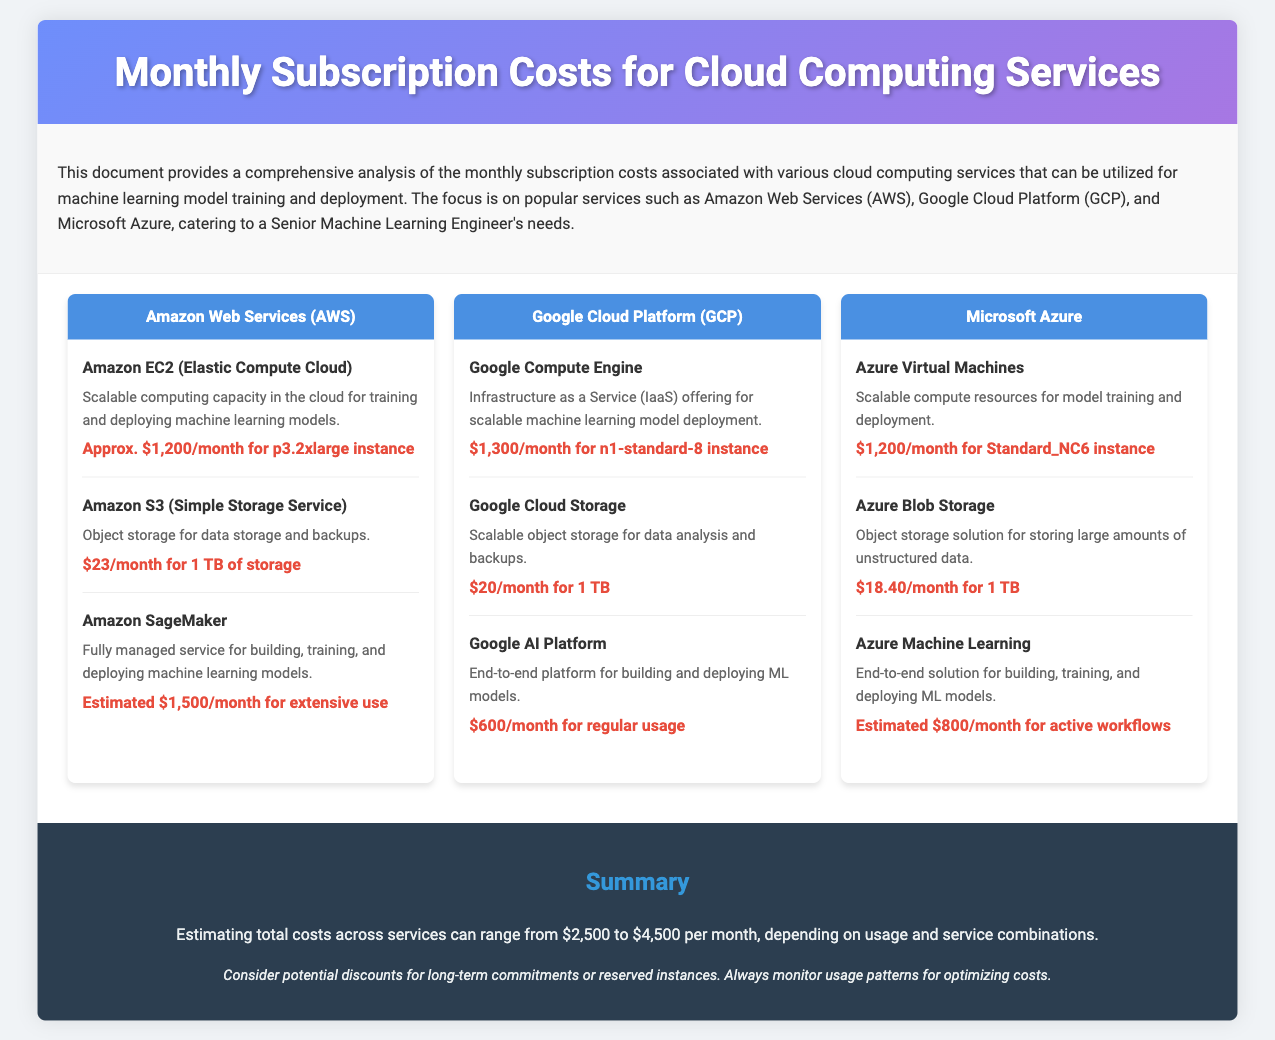What is the cost of Amazon EC2? The cost of Amazon EC2 is specified in the document as approximately $1,200 per month for the p3.2xlarge instance.
Answer: $1,200/month How much does Azure Blob Storage cost? The document lists the cost of Azure Blob Storage as $18.40 per month for 1 TB.
Answer: $18.40/month What is the estimated monthly cost for Google AI Platform? The estimated monthly cost for Google AI Platform is mentioned as $600 for regular usage.
Answer: $600/month Which cloud service offers fully managed model training and deployment? The document describes Amazon SageMaker and Azure Machine Learning as fully managed services for building, training, and deploying machine learning models.
Answer: Amazon SageMaker and Azure Machine Learning What is the total cost range of all services mentioned? The document provides a total cost range estimate across services, indicating it can be between $2,500 to $4,500 per month depending on usage and service combinations.
Answer: $2,500 to $4,500 What is the description of Google Cloud Storage? The description provided in the document states that Google Cloud Storage is scalable object storage for data analysis and backups.
Answer: Scalable object storage for data analysis and backups What are the two primary factors influencing cloud computing expenses according to the summary? The summary suggests that potential discounts for long-term commitments or reserved instances and monitoring usage patterns are key factors in optimizing costs.
Answer: Discounts and usage monitoring How many main cloud providers are discussed in the document? The document discusses three main cloud providers: Amazon Web Services, Google Cloud Platform, and Microsoft Azure.
Answer: Three What type of instance does Azure Virtual Machines use? The document specifies that Azure Virtual Machines uses the Standard_NC6 instance type for scalable compute resources.
Answer: Standard_NC6 